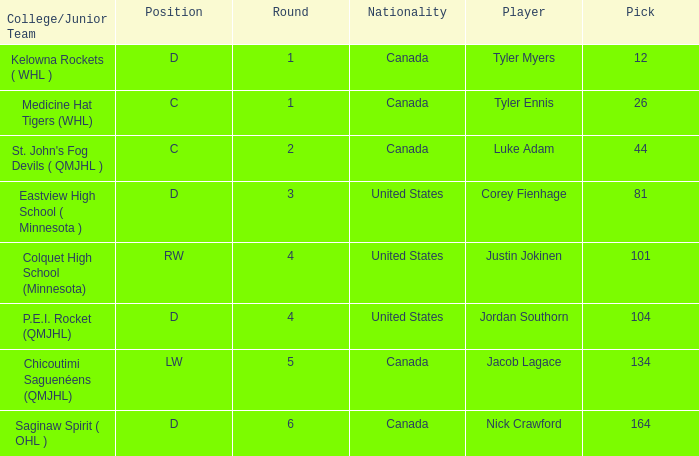What is the average round of the rw position player from the United States? 4.0. 